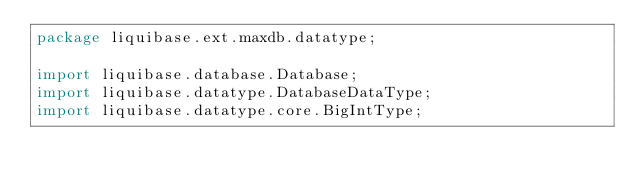<code> <loc_0><loc_0><loc_500><loc_500><_Java_>package liquibase.ext.maxdb.datatype;

import liquibase.database.Database;
import liquibase.datatype.DatabaseDataType;
import liquibase.datatype.core.BigIntType;</code> 